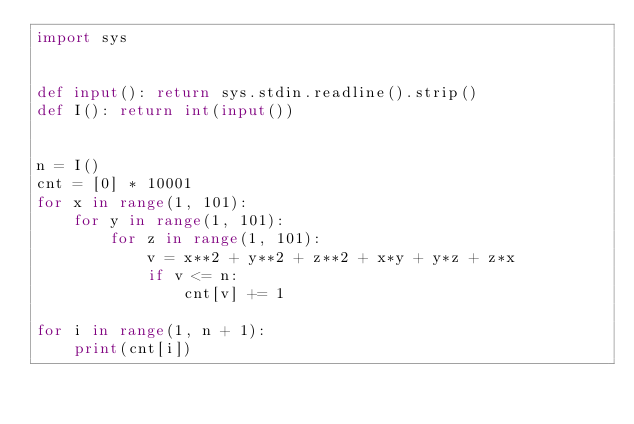Convert code to text. <code><loc_0><loc_0><loc_500><loc_500><_Python_>import sys


def input(): return sys.stdin.readline().strip()
def I(): return int(input())


n = I()
cnt = [0] * 10001
for x in range(1, 101):
    for y in range(1, 101):
        for z in range(1, 101):
            v = x**2 + y**2 + z**2 + x*y + y*z + z*x
            if v <= n:
                cnt[v] += 1

for i in range(1, n + 1):
    print(cnt[i])
</code> 